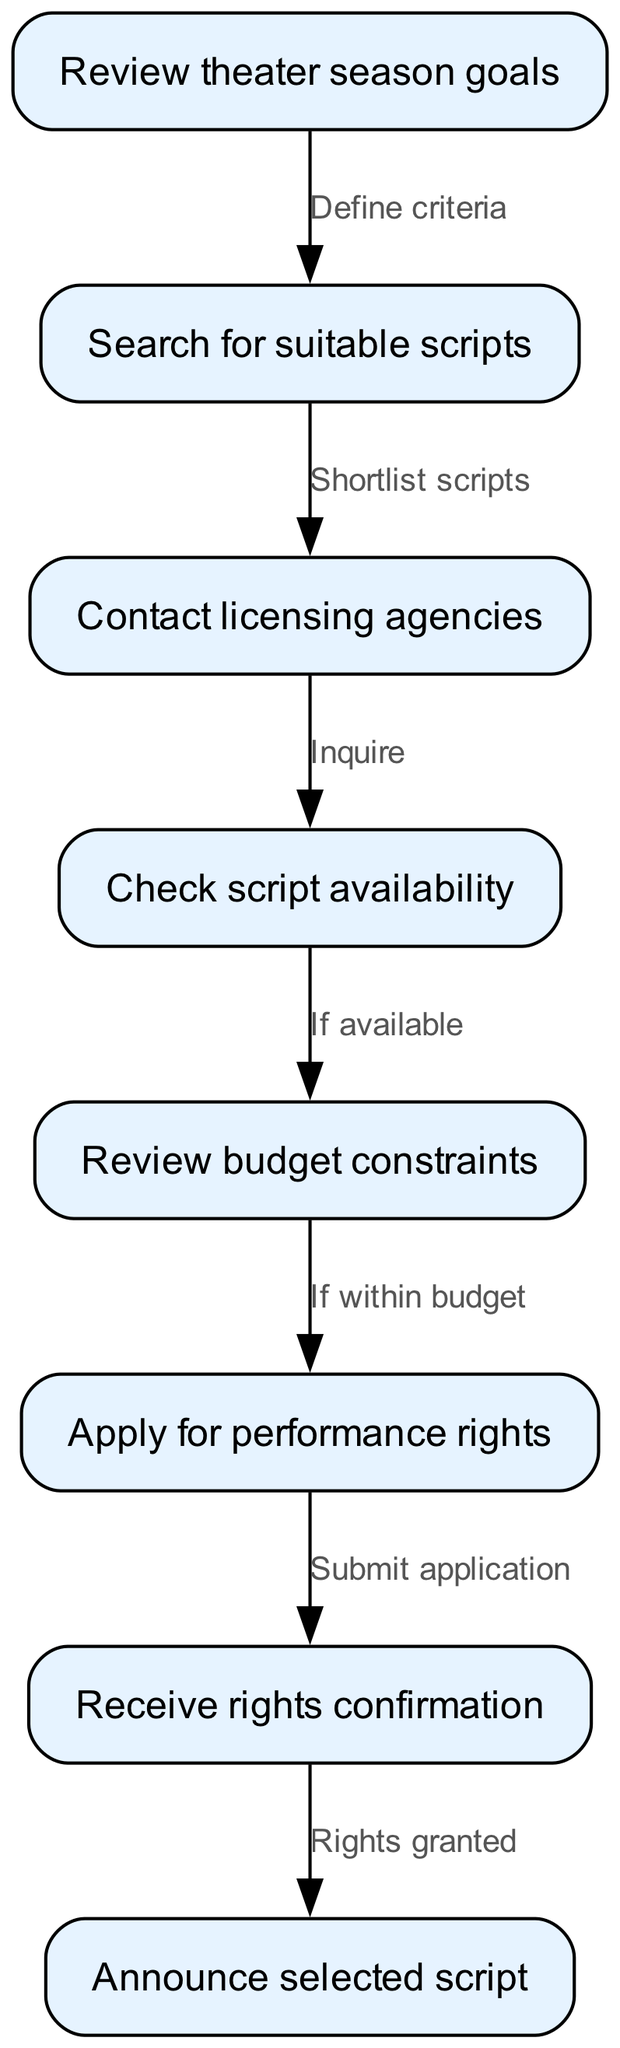What is the starting node of the workflow? The starting node is "Review theater season goals". This is indicated as the first node in the diagram with no preceding nodes.
Answer: Review theater season goals How many nodes are there in total? The diagram lists a total of eight nodes. This can be counted directly from the nodes provided.
Answer: 8 What does the node "Apply for performance rights" lead to? The node "Apply for performance rights" leads to the node "Receive rights confirmation". This connection is shown as an edge between these two nodes in the diagram.
Answer: Receive rights confirmation What must be checked before applying for performance rights? The budget constraints must be checked before applying for performance rights, as indicated by the edge leading from the "Review budget constraints" node to the "Apply for performance rights" node contingent upon the budget being appropriate.
Answer: Review budget constraints What is the relationship between the nodes "Check script availability" and "Search for suitable scripts"? The relationship is that after contacting licensing agencies, you check script availability based upon the scripts you have shortlisted. This is a sequential flow shown in the diagram where one node leads directly to the other.
Answer: Check script availability If a script is not available, what aspect must be considered next? If the script is not available, the workflow suggests reviewing budget constraints, as that is the next step indicated in the diagram after checking availability.
Answer: Review budget constraints What action follows after receiving rights confirmation? After receiving rights confirmation, the action is to announce the selected script. This is clearly indicated as the next step in the flowchart.
Answer: Announce selected script How are scripts shortlisted according to the diagram? Scripts are shortlisted after defining the criteria set during the review of theater season goals. This indicates a logical flow where criteria are first established.
Answer: Shortlist scripts 